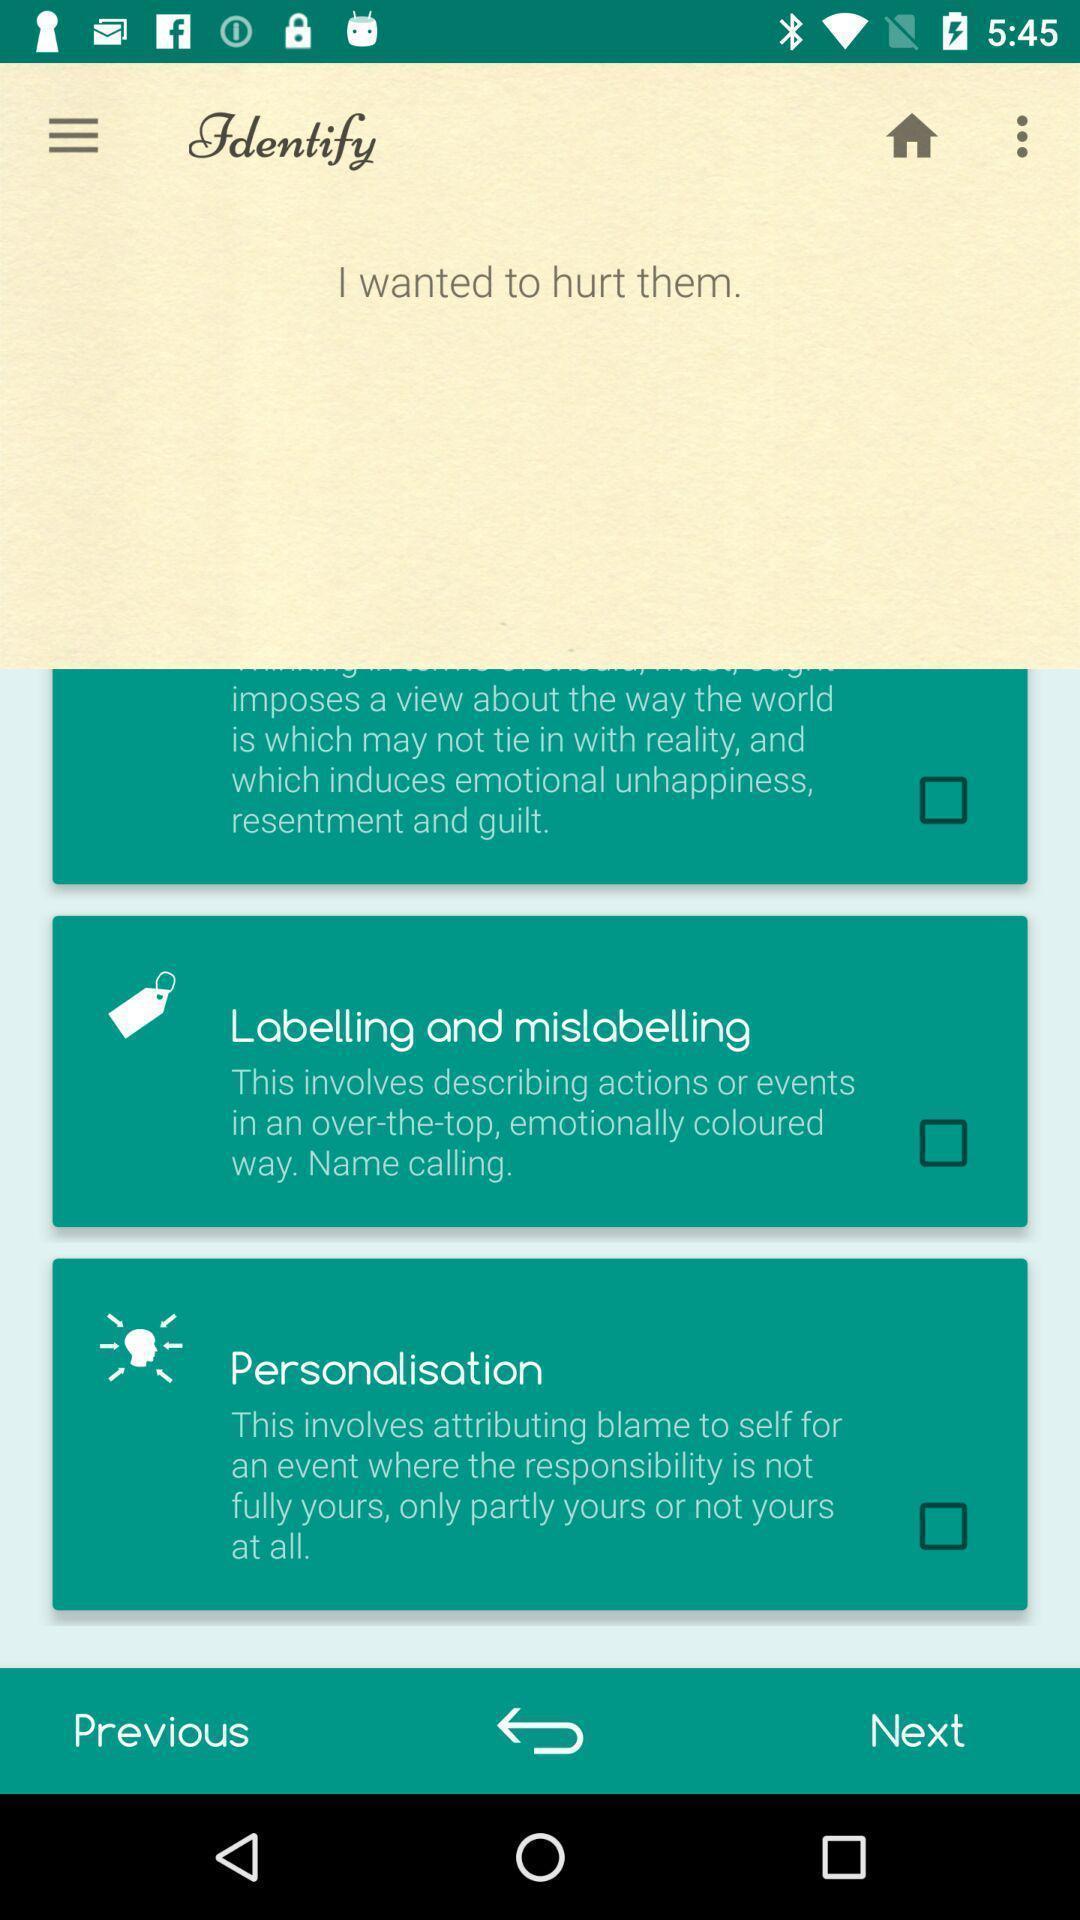Provide a textual representation of this image. Screen displaying the list of features with check boxes. 